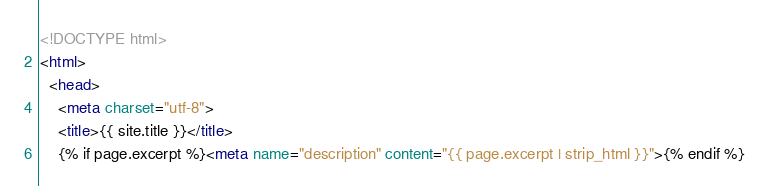Convert code to text. <code><loc_0><loc_0><loc_500><loc_500><_HTML_><!DOCTYPE html>
<html>
  <head>
    <meta charset="utf-8">
    <title>{{ site.title }}</title>
    {% if page.excerpt %}<meta name="description" content="{{ page.excerpt | strip_html }}">{% endif %}</code> 